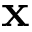<formula> <loc_0><loc_0><loc_500><loc_500>x</formula> 